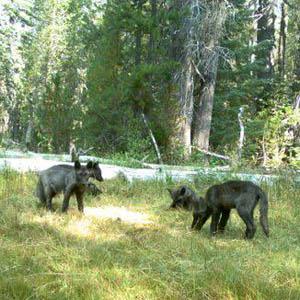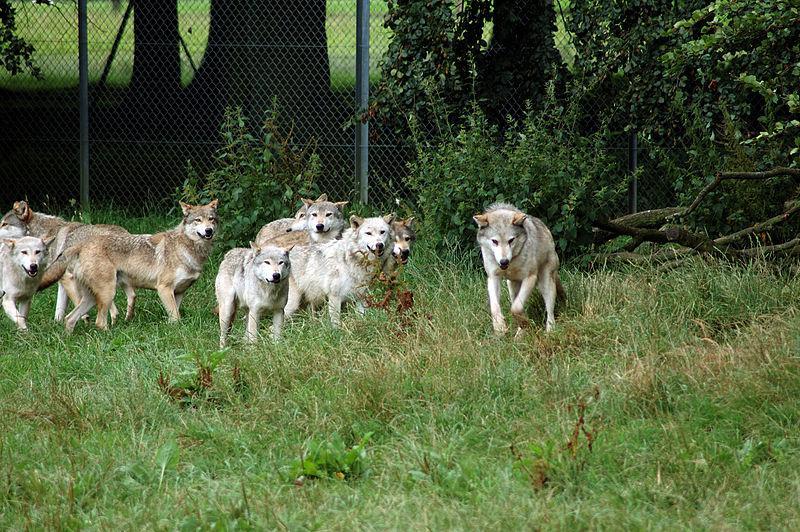The first image is the image on the left, the second image is the image on the right. For the images shown, is this caption "At least three animals are lying down in the grass in the image on the left." true? Answer yes or no. No. 